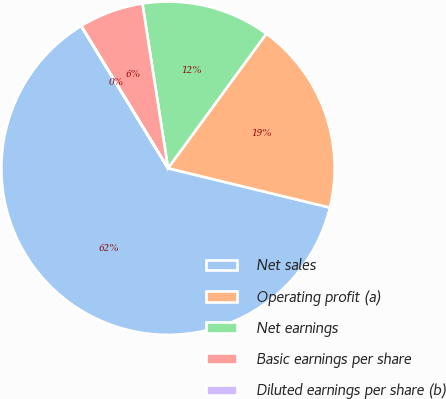Convert chart to OTSL. <chart><loc_0><loc_0><loc_500><loc_500><pie_chart><fcel>Net sales<fcel>Operating profit (a)<fcel>Net earnings<fcel>Basic earnings per share<fcel>Diluted earnings per share (b)<nl><fcel>62.48%<fcel>18.75%<fcel>12.5%<fcel>6.26%<fcel>0.01%<nl></chart> 